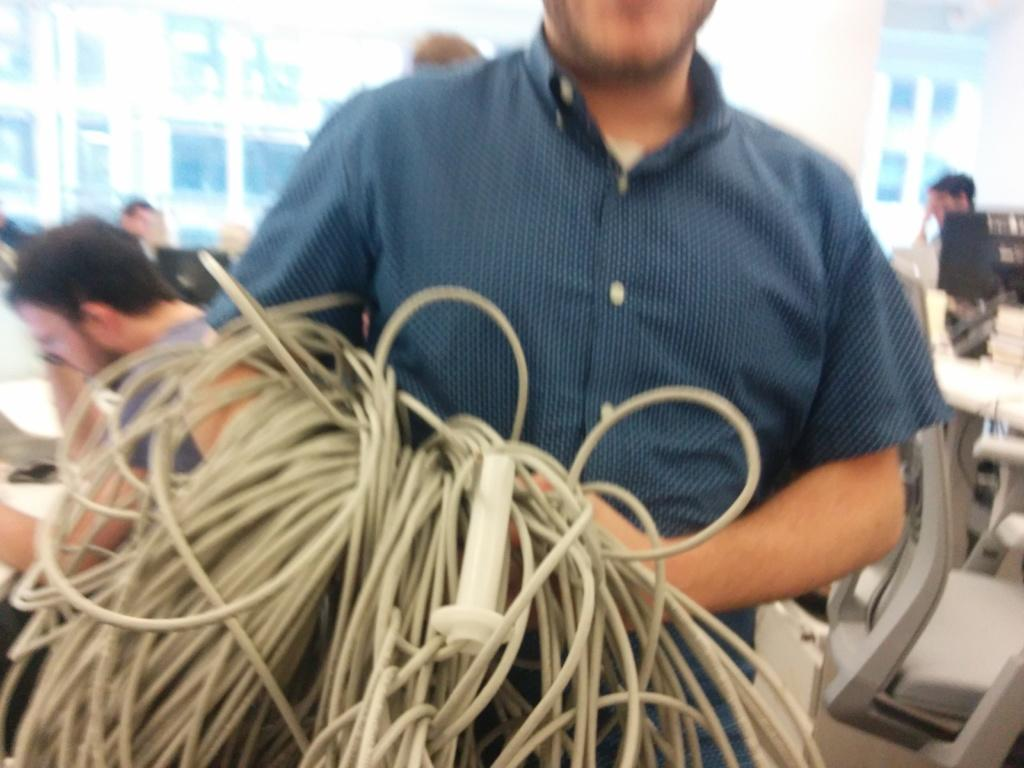What is the main subject of the image? There is a person standing in the middle of the image. What is the person holding in the image? The person is holding some wires. Can you describe the people behind the person? There are people standing and sitting behind the person. What type of furniture can be seen in the image? There are tables visible in the image. What type of lace can be seen on the person's clothing in the image? There is no lace visible on the person's clothing in the image. Can you describe the insect that is crawling on the person's back in the image? There is no insect visible on the person's back in the image. 